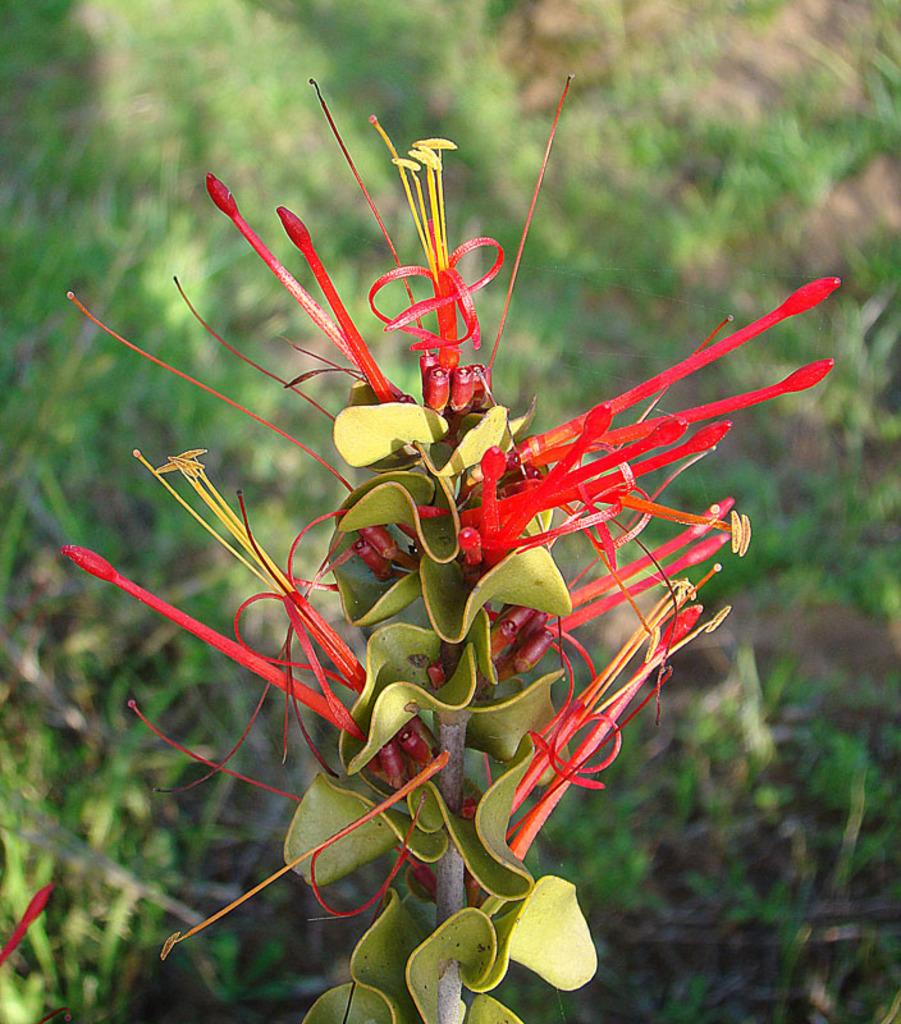What type of plant is shown in the image? The plant in the image has red buds and green leaves. What color are the buds on the plant? The buds on the plant are red. What color are the leaves on the plant? The leaves on the plant are green. What type of vegetation is visible on the ground in the image? There is grass visible on the ground in the image. What type of caption is written on the rail in the image? There is no rail or caption present in the image. 